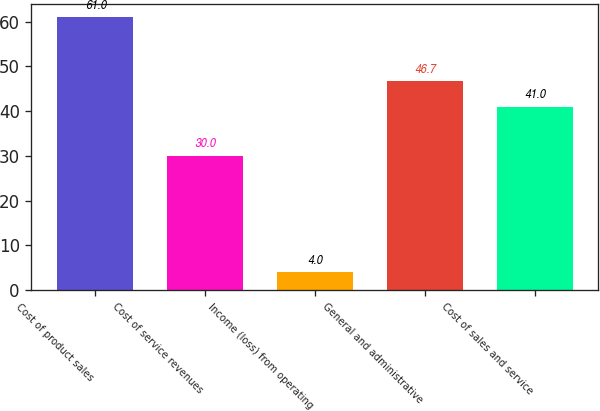Convert chart to OTSL. <chart><loc_0><loc_0><loc_500><loc_500><bar_chart><fcel>Cost of product sales<fcel>Cost of service revenues<fcel>Income (loss) from operating<fcel>General and administrative<fcel>Cost of sales and service<nl><fcel>61<fcel>30<fcel>4<fcel>46.7<fcel>41<nl></chart> 